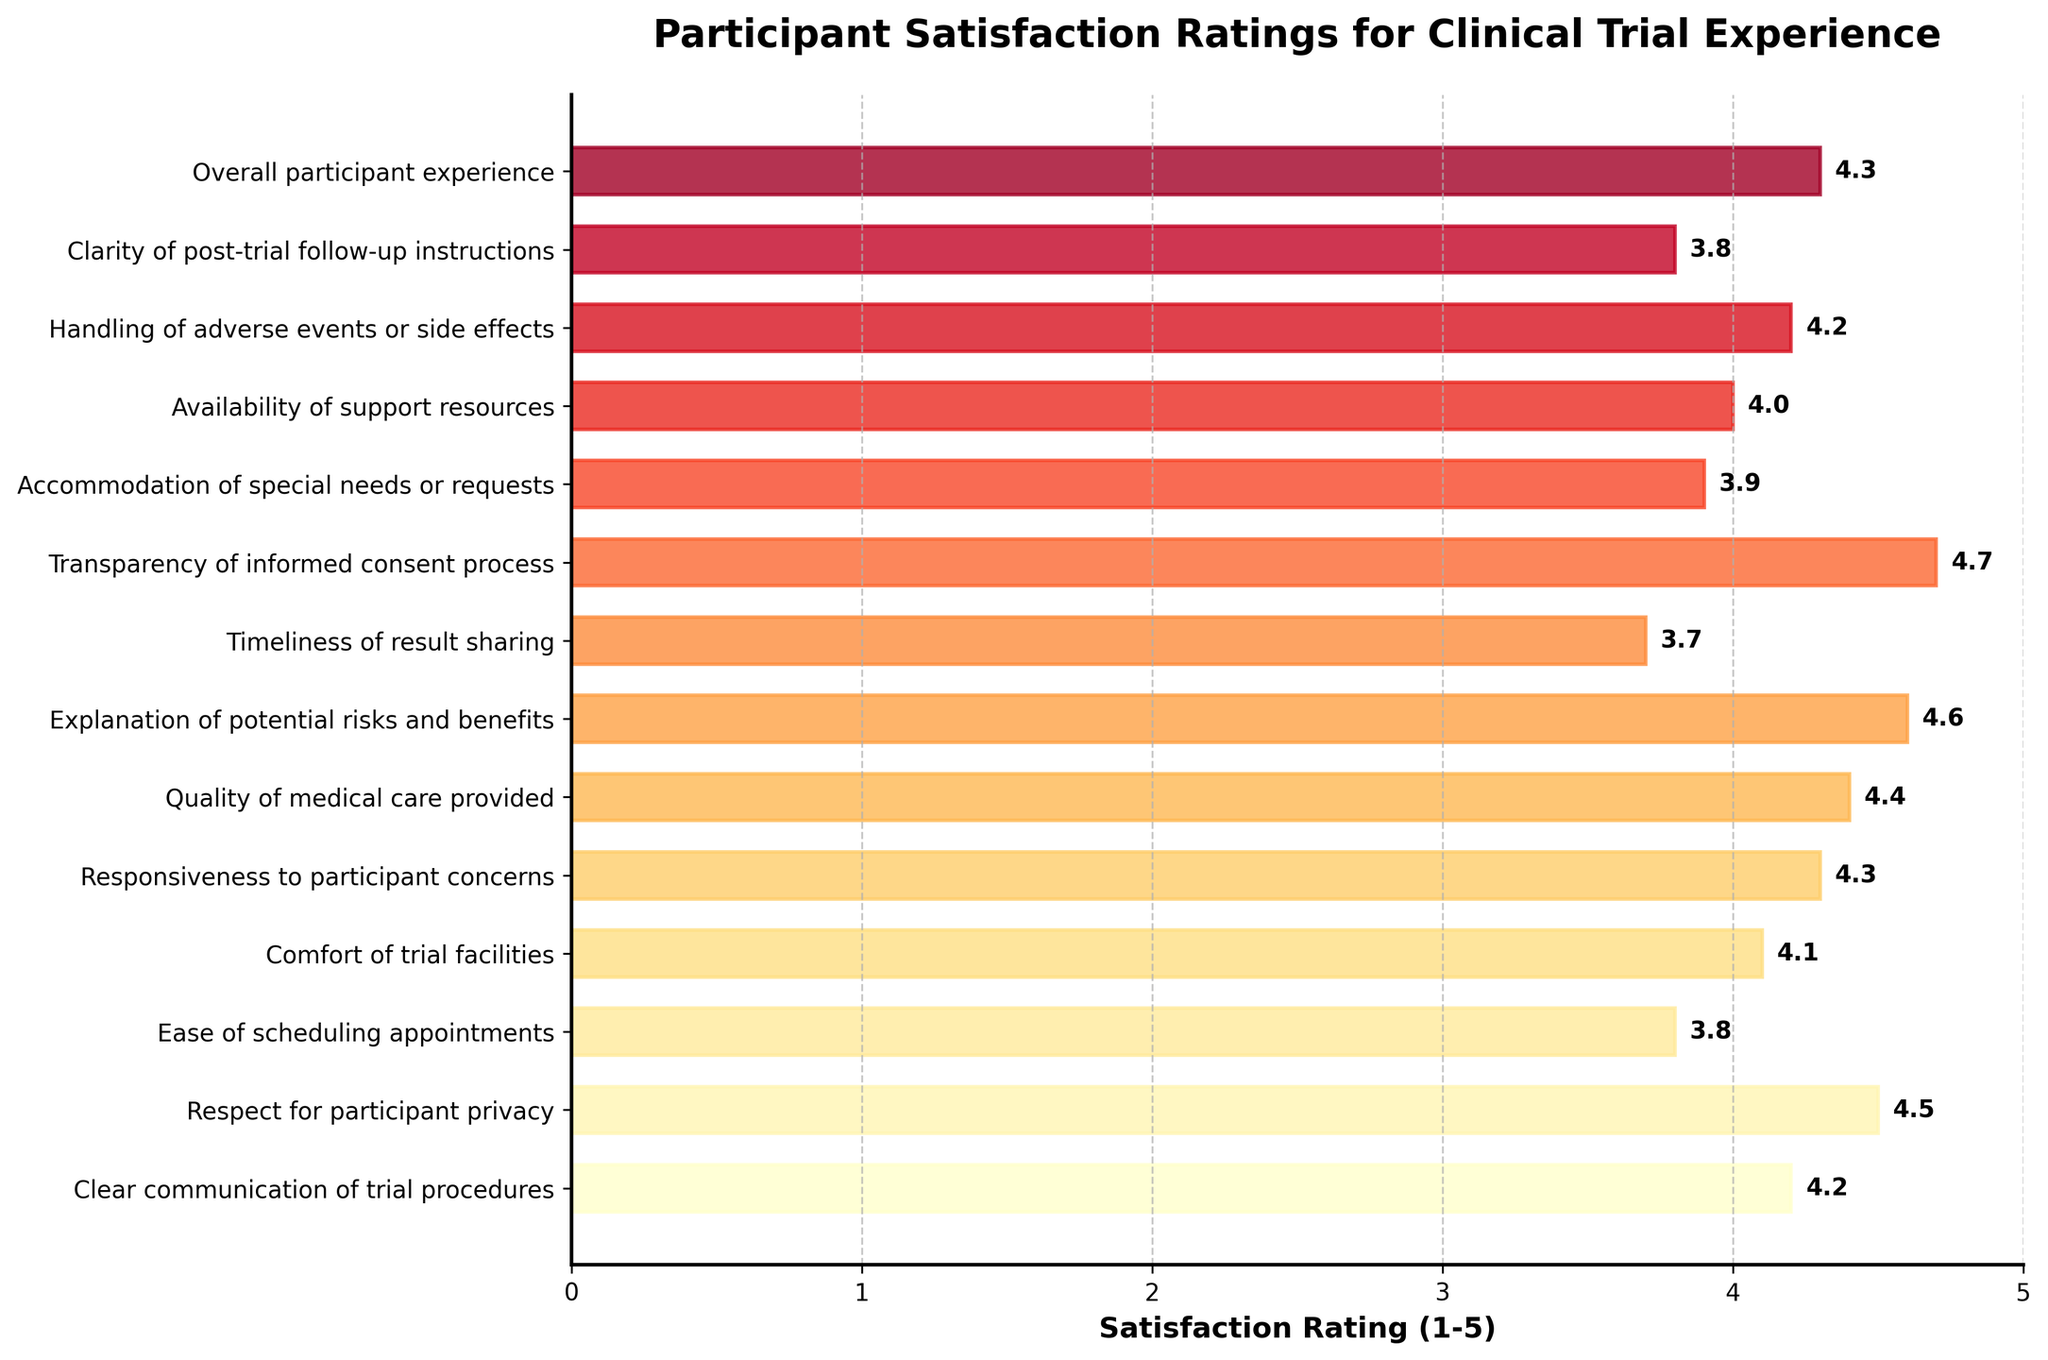What aspect of clinical trial experience received the highest satisfaction rating? Identify the bar with the greatest length, which signifies the highest rating. The "Transparency of informed consent process" has the highest satisfaction rating of 4.7.
Answer: Transparency of informed consent process What is the average satisfaction rating for "Clear communication of trial procedures," "Respect for participant privacy," and "Responsiveness to participant concerns"? Add the ratings of "Clear communication of trial procedures" (4.2), "Respect for participant privacy" (4.5), and "Responsiveness to participant concerns" (4.3), then divide by 3. Sum is 13. Divide by 3 to get approximately 4.3.
Answer: 4.3 Which aspect has a higher satisfaction rating: "Ease of scheduling appointments" or "Clarity of post-trial follow-up instructions"? Compare the ratings of "Ease of scheduling appointments" (3.8) and "Clarity of post-trial follow-up instructions" (3.8). Both have equal ratings.
Answer: Both equal What is the sum of satisfaction ratings for "Accommodation of special needs or requests" and "Availability of support resources"? Add the ratings of "Accommodation of special needs or requests" (3.9) and "Availability of support resources" (4.0). The sum is 7.9.
Answer: 7.9 Which visual feature indicates that the aspect "Timeliness of result sharing" received a lower satisfaction rating than "Comfort of trial facilities"? "Timeliness of result sharing" has a shorter bar length compared to "Comfort of trial facilities," indicating a lower satisfaction rating (3.7 vs. 4.1).
Answer: Shorter bar length How does the satisfaction rating of "Quality of medical care provided" compare to "Transparency of informed consent process"? "Quality of medical care provided" has a rating of 4.4, while "Transparency of informed consent process" has a higher rating of 4.7.
Answer: Lower What aspects have satisfaction ratings higher than 4.5? Identify bars longer than the 4.5 mark. The aspects "Transparency of informed consent process" (4.7) and "Explanation of potential risks and benefits" (4.6) both satisfy this condition.
Answer: Transparency of informed consent process, Explanation of potential risks and benefits What is the median satisfaction rating amongst all aspects? Arrange the ratings in ascending order: 3.7, 3.8, 3.8, 3.9, 4.0, 4.1, 4.2, 4.2, 4.3, 4.3, 4.4, 4.5, 4.6, 4.7. The middle values are 4.2 and 4.3, and their average is 4.25.
Answer: 4.25 Which two aspects have the closest satisfaction ratings? Identify bars with nearly similar lengths. "Ease of scheduling appointments" and "Clarity of post-trial follow-up instructions" have the same rating (3.8).
Answer: Ease of scheduling appointments, Clarity of post-trial follow-up instructions What is the range of satisfaction ratings? The range is calculated by subtracting the lowest rating (3.7 for "Timeliness of result sharing") from the highest rating (4.7 for "Transparency of informed consent process"). The range is 1.0.
Answer: 1.0 